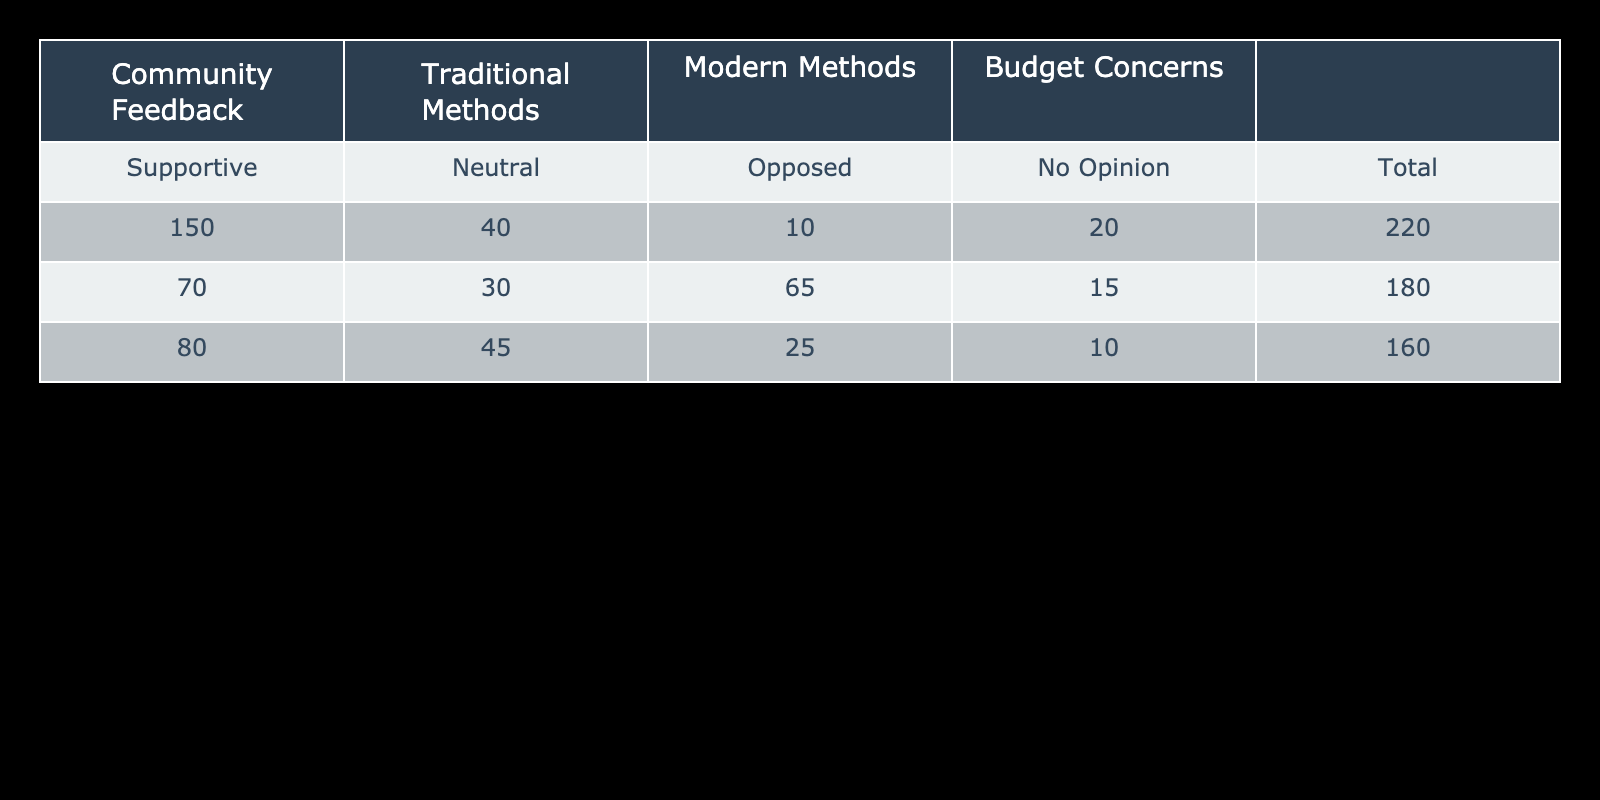What is the total number of people supportive of traditional methods? To find the total number of supportive people for traditional methods, we look at the "Supportive" row under the "Traditional Methods" column, which states 150.
Answer: 150 What percentage of people are neutral about modern methods? The number of neutral people about modern methods is 30. The total number of respondents (sum of traditional and modern methods) is 220 + 180 = 400. To find the percentage: (30/400) * 100 = 7.5%.
Answer: 7.5% Is the total number of people opposed to traditional methods greater than those opposed to modern methods? The number of people opposed to traditional methods is 10, while those opposed to modern methods is 65. Since 10 is not greater than 65, the answer is no.
Answer: No What is the overall number of people concerned about the budget? To find the overall number of people concerned about the budget, we simply look at the "Budget Concerns" column. The total number of people concerned is 160.
Answer: 160 What is the average number of people who have no opinion on all methods? The number of people with no opinion on traditional methods is 20, modern methods is 15, and budget concerns is 10. The total for no opinion is 20 + 15 + 10 = 45. The average is 45/3 = 15.
Answer: 15 What is the difference in support between traditional and modern methods? The number of supporters for traditional methods is 150, and for modern methods, it is 70. The difference is 150 - 70 = 80.
Answer: 80 Are there more supporters of traditional methods than those who are opposed to them? Supporters of traditional methods are 150, and those opposed to them are 10. Since 150 is greater than 10, the answer is yes.
Answer: Yes How many more people are supportive of traditional methods compared to those who have no opinion? The number of supporters is 150 and the number of people with no opinion is 20. The difference is 150 - 20 = 130.
Answer: 130 What proportion of total respondents oppose modern methods? The total number of respondents is 400 (220 support traditional, 180 support modern). Those opposed to modern methods number 65. The proportion can be calculated as 65/400 = 0.1625 or 16.25%.
Answer: 16.25% 